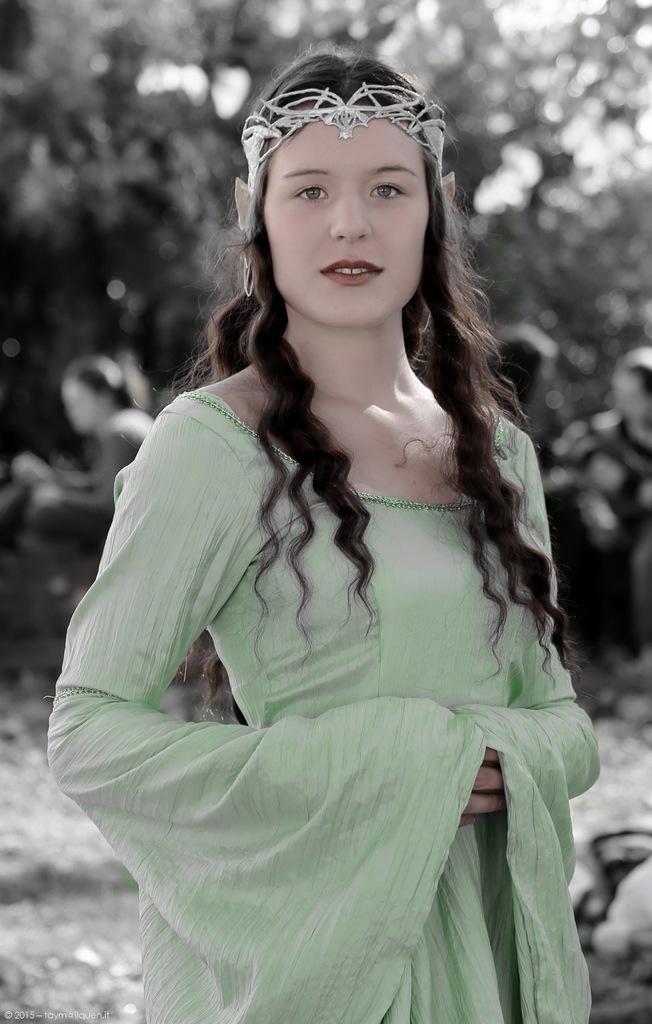Can you describe this image briefly? In this image we can see a person standing and blur background. 